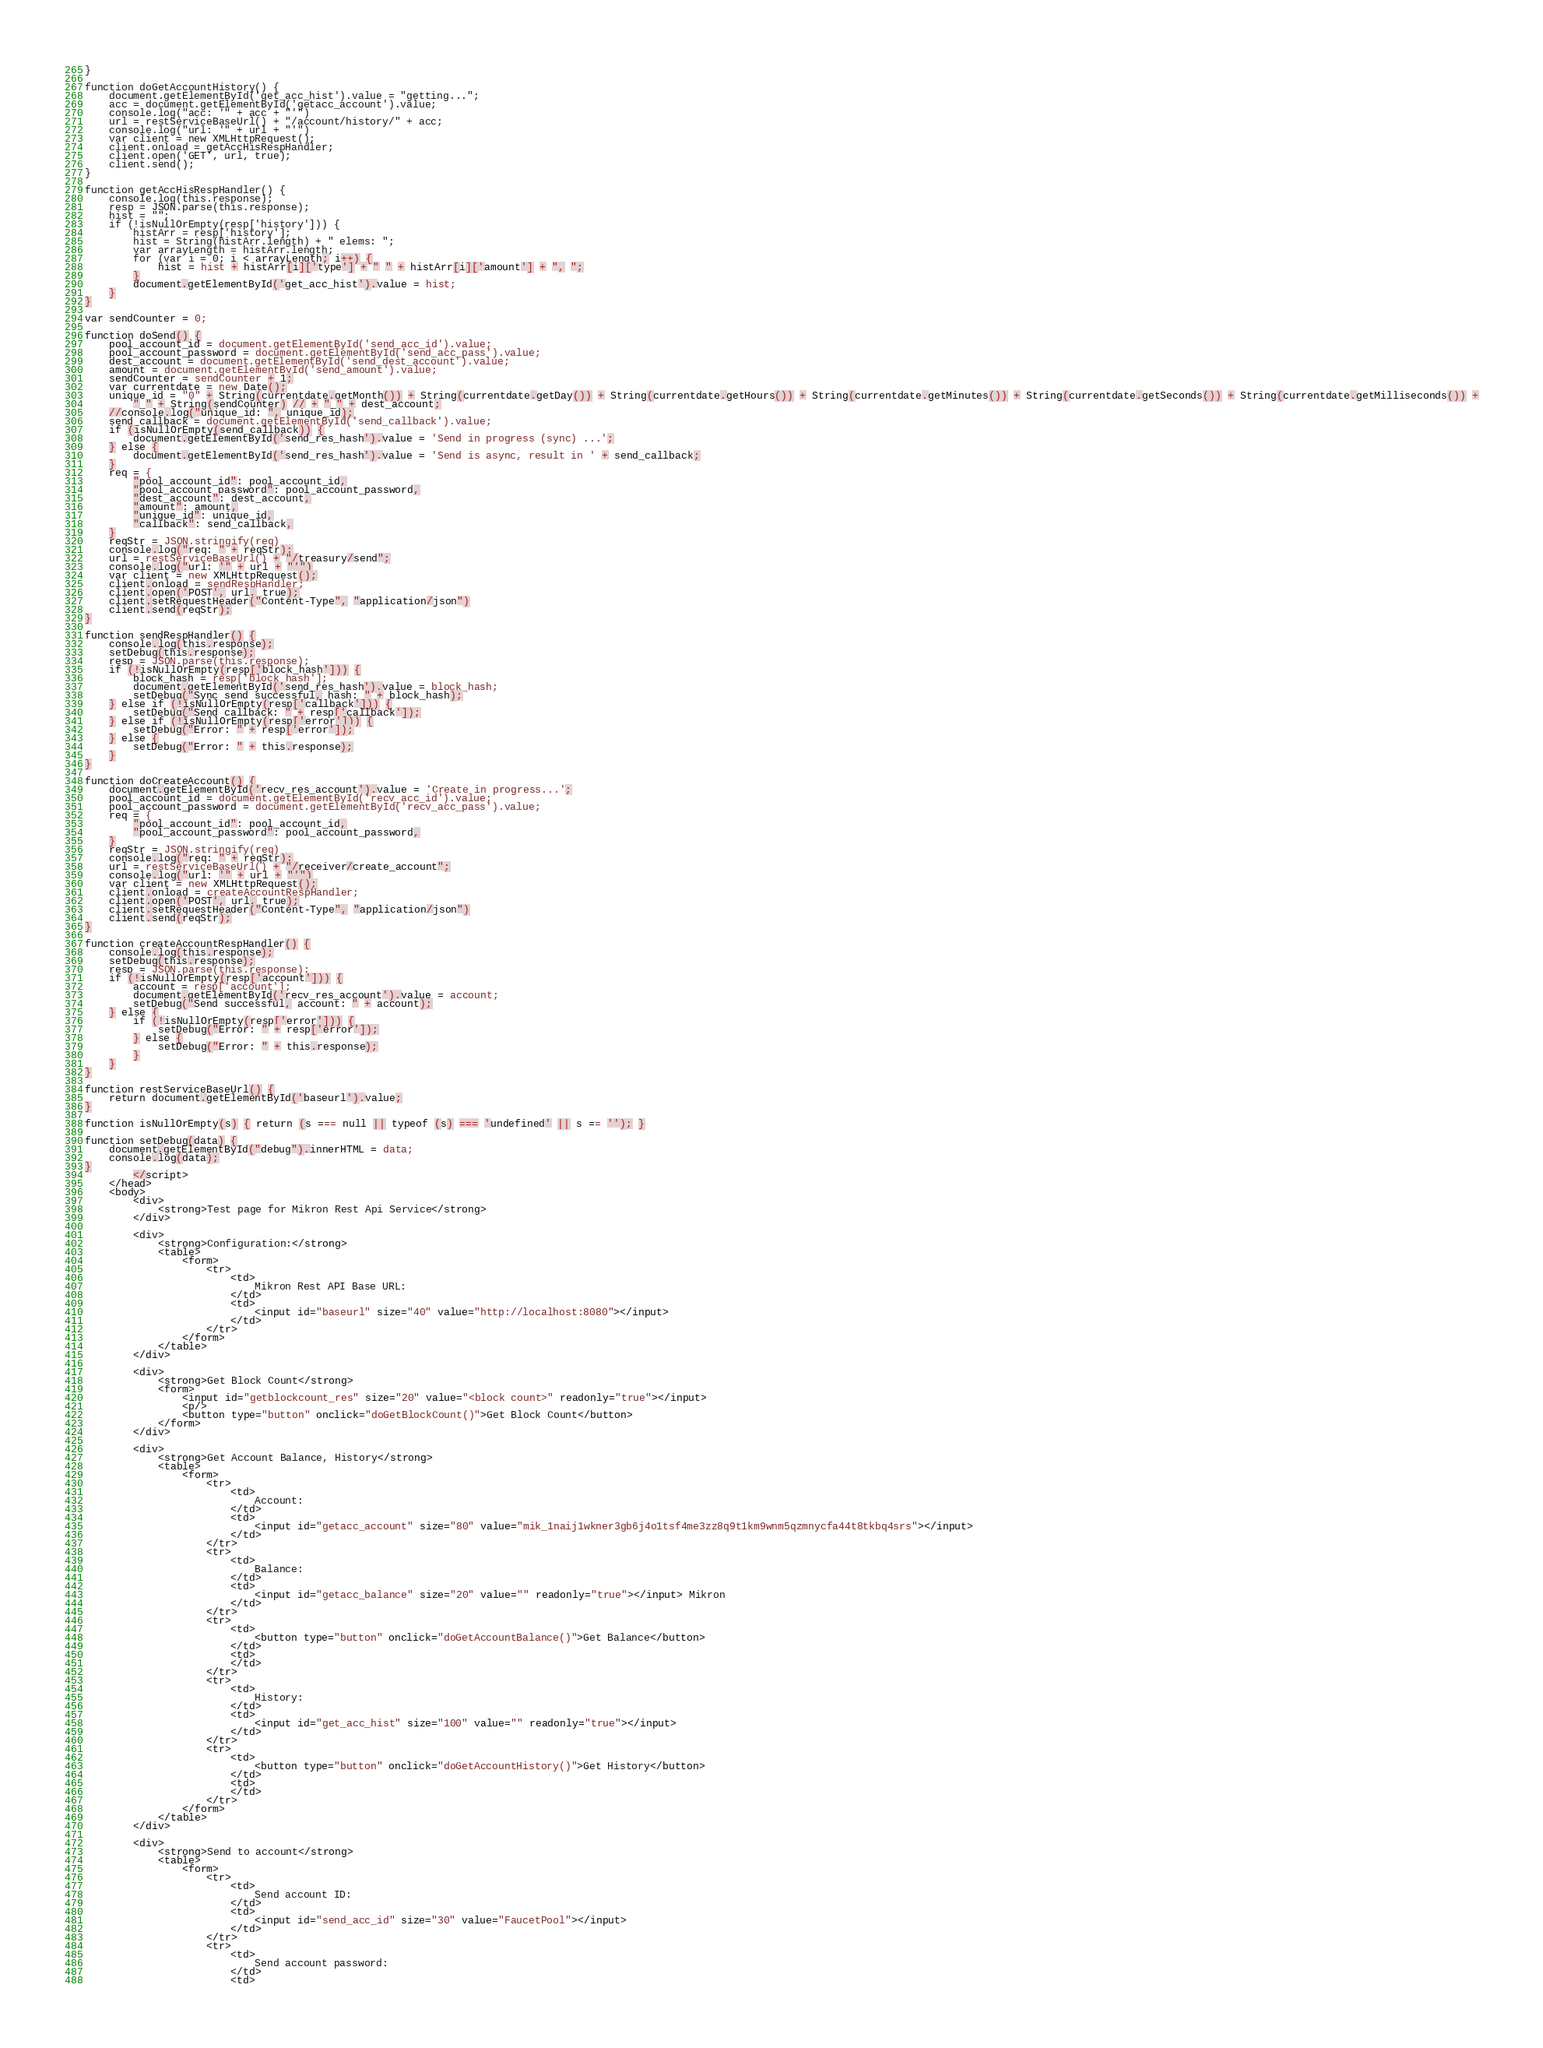<code> <loc_0><loc_0><loc_500><loc_500><_HTML_>}

function doGetAccountHistory() {
    document.getElementById('get_acc_hist').value = "getting...";
    acc = document.getElementById('getacc_account').value;
    console.log("acc: '" + acc + "'")
    url = restServiceBaseUrl() + "/account/history/" + acc;
    console.log("url: '" + url + "'")
    var client = new XMLHttpRequest();
    client.onload = getAccHisRespHandler;
    client.open('GET', url, true);
    client.send();
}

function getAccHisRespHandler() {
    console.log(this.response);
    resp = JSON.parse(this.response);
    hist = "";
    if (!isNullOrEmpty(resp['history'])) {
        histArr = resp['history'];
        hist = String(histArr.length) + " elems: ";
        var arrayLength = histArr.length;
        for (var i = 0; i < arrayLength; i++) {
            hist = hist + histArr[i]['type'] + " " + histArr[i]['amount'] + ", ";
        }
        document.getElementById('get_acc_hist').value = hist;
    }
}

var sendCounter = 0;

function doSend() {
    pool_account_id = document.getElementById('send_acc_id').value;
    pool_account_password = document.getElementById('send_acc_pass').value;
    dest_account = document.getElementById('send_dest_account').value;
    amount = document.getElementById('send_amount').value;
    sendCounter = sendCounter + 1;
    var currentdate = new Date();
    unique_id = "0" + String(currentdate.getMonth()) + String(currentdate.getDay()) + String(currentdate.getHours()) + String(currentdate.getMinutes()) + String(currentdate.getSeconds()) + String(currentdate.getMilliseconds()) +
        "_" + String(sendCounter) // + "_" + dest_account;
    //console.log("unique_id: ", unique_id);
    send_callback = document.getElementById('send_callback').value;
    if (isNullOrEmpty(send_callback)) {
        document.getElementById('send_res_hash').value = 'Send in progress (sync) ...';
    } else {
        document.getElementById('send_res_hash').value = 'Send is async, result in ' + send_callback;
    }
    req = {
        "pool_account_id": pool_account_id,
        "pool_account_password": pool_account_password,
        "dest_account": dest_account,
        "amount": amount, 
        "unique_id": unique_id,
        "callback": send_callback,
    }
    reqStr = JSON.stringify(req)
    console.log("req: " + reqStr);
    url = restServiceBaseUrl() + "/treasury/send";
    console.log("url: '" + url + "'")
    var client = new XMLHttpRequest();
    client.onload = sendRespHandler;
    client.open('POST', url, true);
    client.setRequestHeader("Content-Type", "application/json")
    client.send(reqStr);
}

function sendRespHandler() {
    console.log(this.response);
    setDebug(this.response);
    resp = JSON.parse(this.response);
    if (!isNullOrEmpty(resp['block_hash'])) {
        block_hash = resp['block_hash'];
        document.getElementById('send_res_hash').value = block_hash;
        setDebug("Sync send successful, hash: " + block_hash);
    } else if (!isNullOrEmpty(resp['callback'])) {
        setDebug("Send callback: " + resp['callback']);
    } else if (!isNullOrEmpty(resp['error'])) {
        setDebug("Error: " + resp['error']);
    } else {
        setDebug("Error: " + this.response);
    }
}

function doCreateAccount() {
    document.getElementById('recv_res_account').value = 'Create in progress...';
    pool_account_id = document.getElementById('recv_acc_id').value;
    pool_account_password = document.getElementById('recv_acc_pass').value;
    req = {
        "pool_account_id": pool_account_id,
        "pool_account_password": pool_account_password,
    }
    reqStr = JSON.stringify(req)
    console.log("req: " + reqStr);
    url = restServiceBaseUrl() + "/receiver/create_account";
    console.log("url: '" + url + "'")
    var client = new XMLHttpRequest();
    client.onload = createAccountRespHandler;
    client.open('POST', url, true);
    client.setRequestHeader("Content-Type", "application/json")
    client.send(reqStr);
}

function createAccountRespHandler() {
    console.log(this.response);
    setDebug(this.response);
    resp = JSON.parse(this.response);
    if (!isNullOrEmpty(resp['account'])) {
        account = resp['account'];
        document.getElementById('recv_res_account').value = account;
        setDebug("Send successful, account: " + account);
    } else {
        if (!isNullOrEmpty(resp['error'])) {
            setDebug("Error: " + resp['error']);
        } else {
            setDebug("Error: " + this.response);
        }
    }
}

function restServiceBaseUrl() {
    return document.getElementById('baseurl').value;
}

function isNullOrEmpty(s) { return (s === null || typeof (s) === 'undefined' || s == ''); }

function setDebug(data) {
    document.getElementById("debug").innerHTML = data;
    console.log(data);
}
        </script>
    </head>
    <body>
        <div>
            <strong>Test page for Mikron Rest Api Service</strong>
        </div>

        <div>
            <strong>Configuration:</strong>
            <table>
                <form>
                    <tr>
                        <td>
                            Mikron Rest API Base URL:
                        </td>
                        <td>
                            <input id="baseurl" size="40" value="http://localhost:8080"></input>
                        </td>
                    </tr>
                </form>
            </table>
        </div>

        <div>
            <strong>Get Block Count</strong>
            <form>
                <input id="getblockcount_res" size="20" value="<block count>" readonly="true"></input>
                <p/>
                <button type="button" onclick="doGetBlockCount()">Get Block Count</button>
            </form>
        </div>

        <div>
            <strong>Get Account Balance, History</strong>
            <table>
                <form>
                    <tr>
                        <td>
                            Account:
                        </td>
                        <td>
                            <input id="getacc_account" size="80" value="mik_1naij1wkner3gb6j4o1tsf4me3zz8q9t1km9wnm5qzmnycfa44t8tkbq4srs"></input>
                        </td>
                    </tr>
                    <tr>
                        <td>
                            Balance:
                        </td>
                        <td>
                            <input id="getacc_balance" size="20" value="" readonly="true"></input> Mikron
                        </td>
                    </tr>
                    <tr>
                        <td>
                            <button type="button" onclick="doGetAccountBalance()">Get Balance</button>
                        </td>
                        <td>
                        </td>
                    </tr>
                    <tr>
                        <td>
                            History:
                        </td>
                        <td>
                            <input id="get_acc_hist" size="100" value="" readonly="true"></input>
                        </td>
                    </tr>
                    <tr>
                        <td>
                            <button type="button" onclick="doGetAccountHistory()">Get History</button>
                        </td>
                        <td>
                        </td>
                    </tr>
                </form>
            </table>
        </div>

        <div>
            <strong>Send to account</strong>
            <table>
                <form>
                    <tr>
                        <td>
                            Send account ID:
                        </td>
                        <td>
                            <input id="send_acc_id" size="30" value="FaucetPool"></input>
                        </td>
                    </tr>
                    <tr>
                        <td>
                            Send account password:
                        </td>
                        <td></code> 